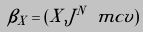Convert formula to latex. <formula><loc_0><loc_0><loc_500><loc_500>\beta _ { X } = ( X , J ^ { N } \ m c v )</formula> 